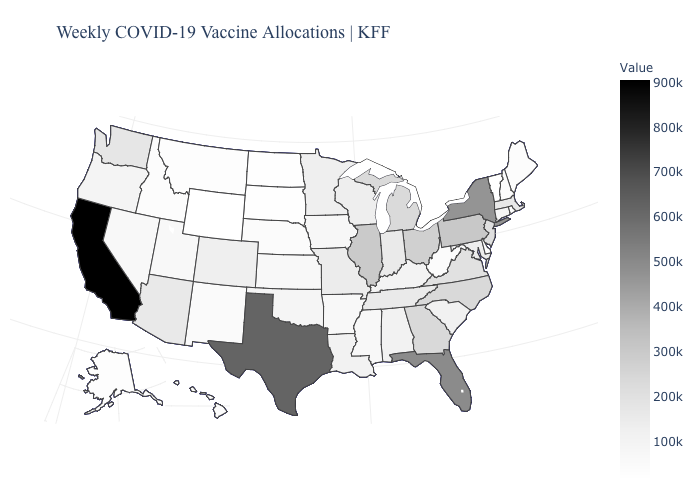Among the states that border Rhode Island , does Massachusetts have the highest value?
Write a very short answer. Yes. Does Texas have the highest value in the South?
Give a very brief answer. Yes. Does New York have the highest value in the Northeast?
Quick response, please. Yes. Is the legend a continuous bar?
Be succinct. Yes. Which states have the highest value in the USA?
Be succinct. California. Does Minnesota have the lowest value in the USA?
Be succinct. No. Which states have the highest value in the USA?
Be succinct. California. Does Wyoming have the lowest value in the USA?
Give a very brief answer. Yes. Among the states that border Vermont , which have the highest value?
Write a very short answer. New York. Which states have the highest value in the USA?
Concise answer only. California. 